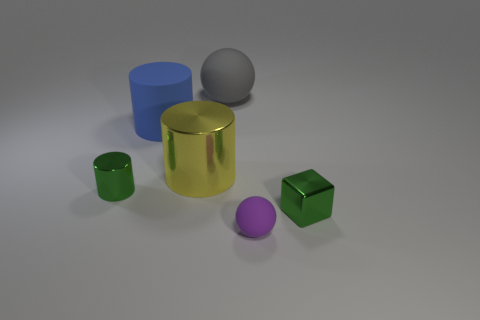What shape is the thing that is the same color as the metallic cube?
Offer a very short reply. Cylinder. What size is the gray matte object that is behind the small rubber object?
Your response must be concise. Large. What number of large matte objects have the same shape as the yellow shiny object?
Provide a short and direct response. 1. What shape is the big blue thing that is the same material as the big ball?
Give a very brief answer. Cylinder. How many cyan things are either small rubber spheres or tiny metallic cubes?
Make the answer very short. 0. There is a large yellow metallic thing; are there any small green cylinders right of it?
Your answer should be very brief. No. There is a big rubber thing right of the blue thing; is it the same shape as the matte object in front of the small metal block?
Offer a very short reply. Yes. There is a large yellow thing that is the same shape as the blue thing; what is it made of?
Provide a short and direct response. Metal. What number of cylinders are either big blue matte things or big matte things?
Your answer should be compact. 1. How many tiny green balls are the same material as the blue cylinder?
Make the answer very short. 0. 